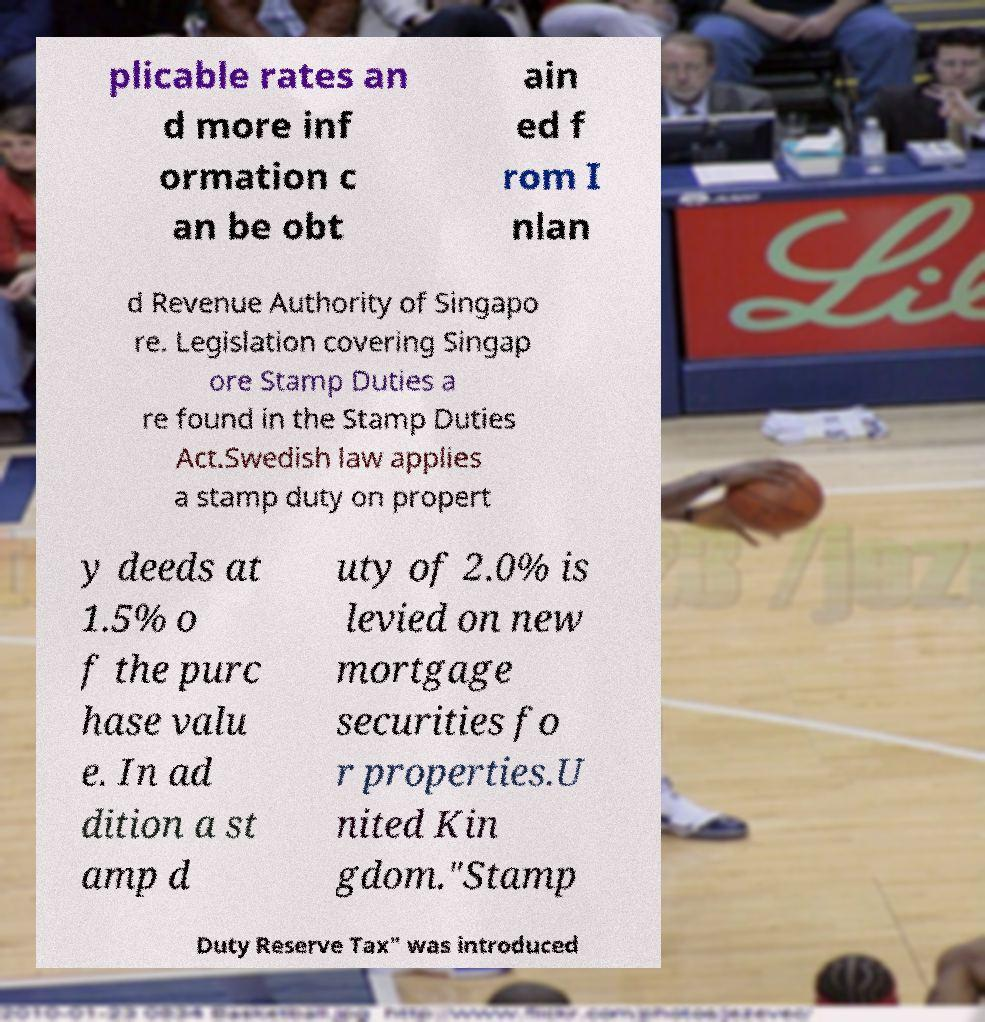What messages or text are displayed in this image? I need them in a readable, typed format. plicable rates an d more inf ormation c an be obt ain ed f rom I nlan d Revenue Authority of Singapo re. Legislation covering Singap ore Stamp Duties a re found in the Stamp Duties Act.Swedish law applies a stamp duty on propert y deeds at 1.5% o f the purc hase valu e. In ad dition a st amp d uty of 2.0% is levied on new mortgage securities fo r properties.U nited Kin gdom."Stamp Duty Reserve Tax" was introduced 